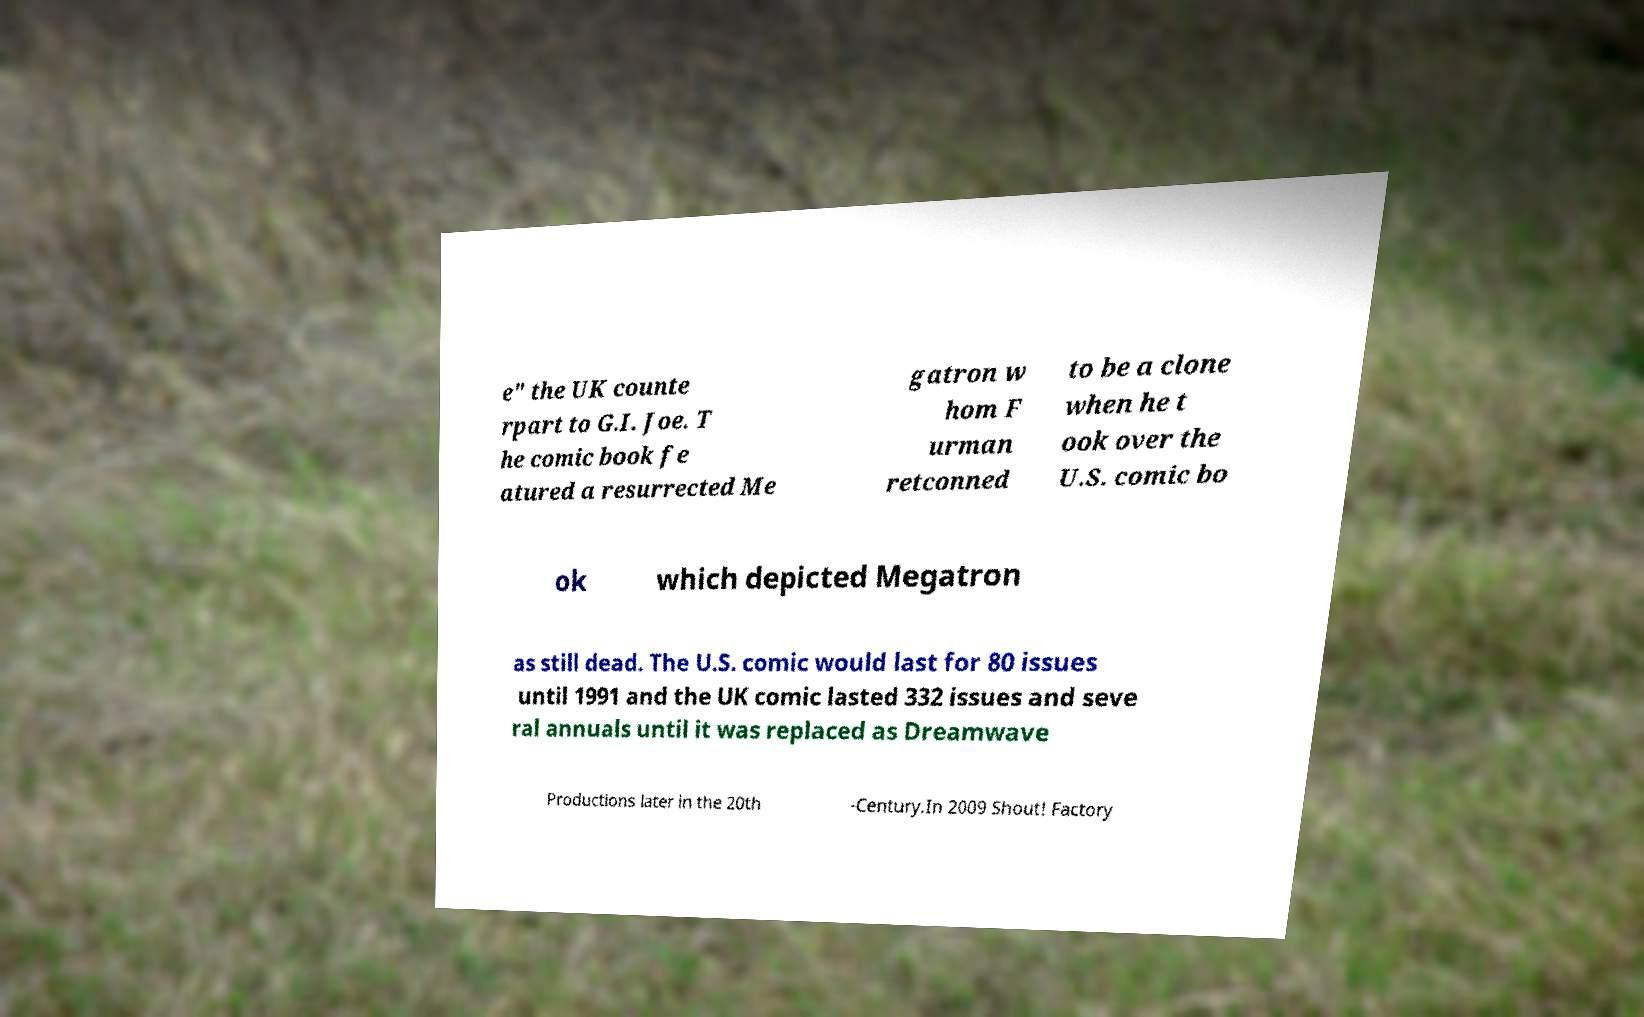What messages or text are displayed in this image? I need them in a readable, typed format. e" the UK counte rpart to G.I. Joe. T he comic book fe atured a resurrected Me gatron w hom F urman retconned to be a clone when he t ook over the U.S. comic bo ok which depicted Megatron as still dead. The U.S. comic would last for 80 issues until 1991 and the UK comic lasted 332 issues and seve ral annuals until it was replaced as Dreamwave Productions later in the 20th -Century.In 2009 Shout! Factory 